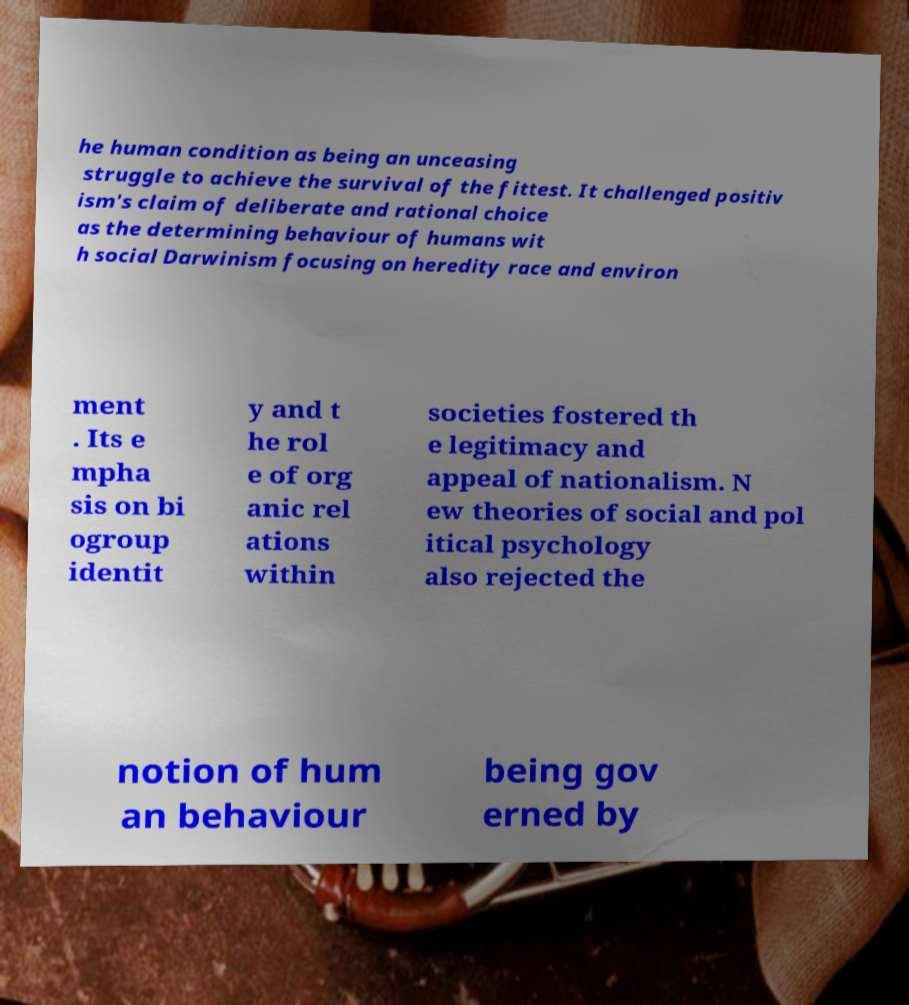Please read and relay the text visible in this image. What does it say? he human condition as being an unceasing struggle to achieve the survival of the fittest. It challenged positiv ism's claim of deliberate and rational choice as the determining behaviour of humans wit h social Darwinism focusing on heredity race and environ ment . Its e mpha sis on bi ogroup identit y and t he rol e of org anic rel ations within societies fostered th e legitimacy and appeal of nationalism. N ew theories of social and pol itical psychology also rejected the notion of hum an behaviour being gov erned by 